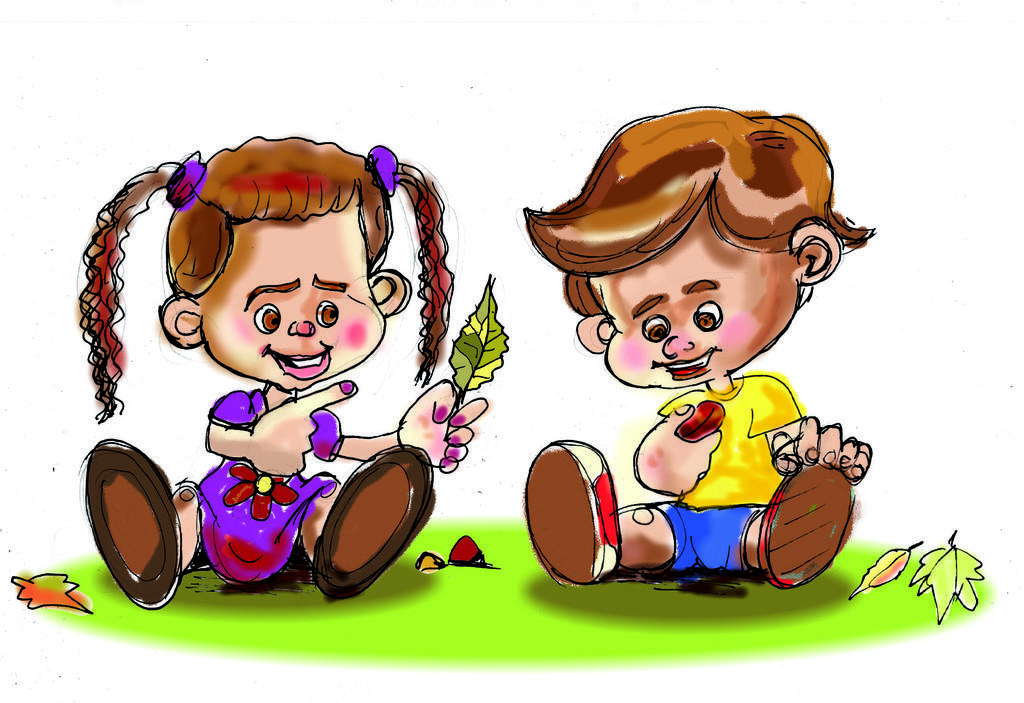What subjects are depicted in the painting? The painting depicts a girl and a boy. What are the girl and boy doing in the painting? Both the girl and boy are sitting on a platform. Can you describe any specific details about the girl in the painting? Yes, there is a girl holding a leaf in the painting. What type of test is the boy taking in the painting? There is no test present in the painting; it depicts a girl and a boy sitting on a platform. 